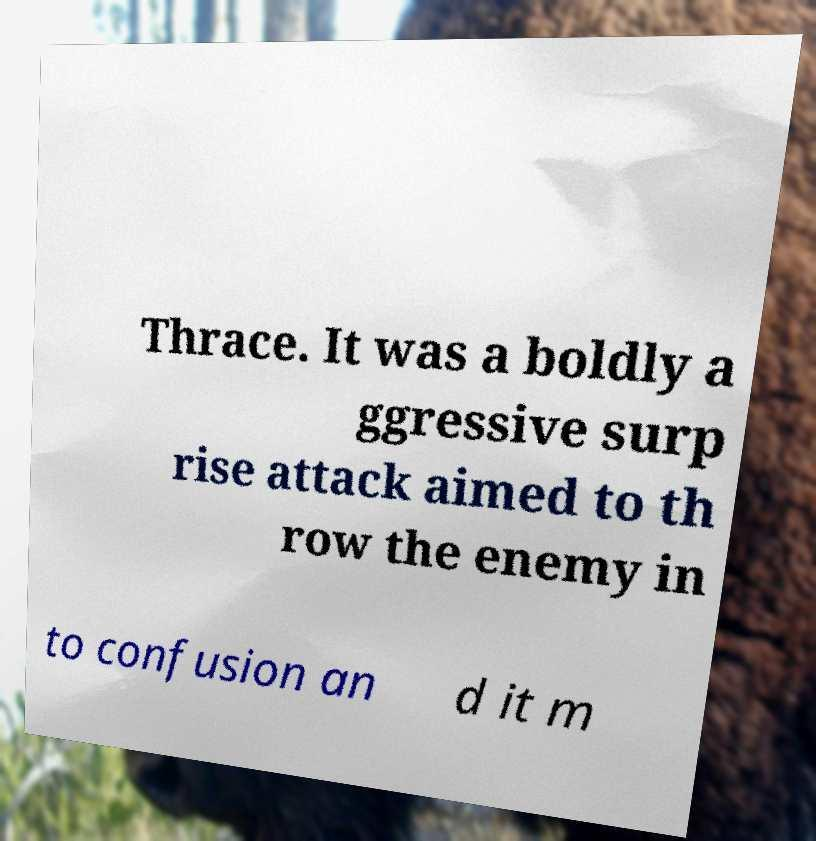What messages or text are displayed in this image? I need them in a readable, typed format. Thrace. It was a boldly a ggressive surp rise attack aimed to th row the enemy in to confusion an d it m 